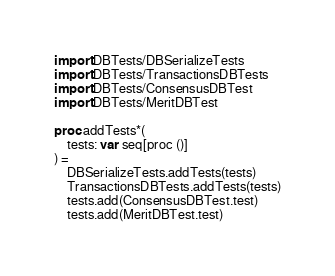Convert code to text. <code><loc_0><loc_0><loc_500><loc_500><_Nim_>import DBTests/DBSerializeTests
import DBTests/TransactionsDBTests
import DBTests/ConsensusDBTest
import DBTests/MeritDBTest

proc addTests*(
    tests: var seq[proc ()]
) =
    DBSerializeTests.addTests(tests)
    TransactionsDBTests.addTests(tests)
    tests.add(ConsensusDBTest.test)
    tests.add(MeritDBTest.test)
</code> 